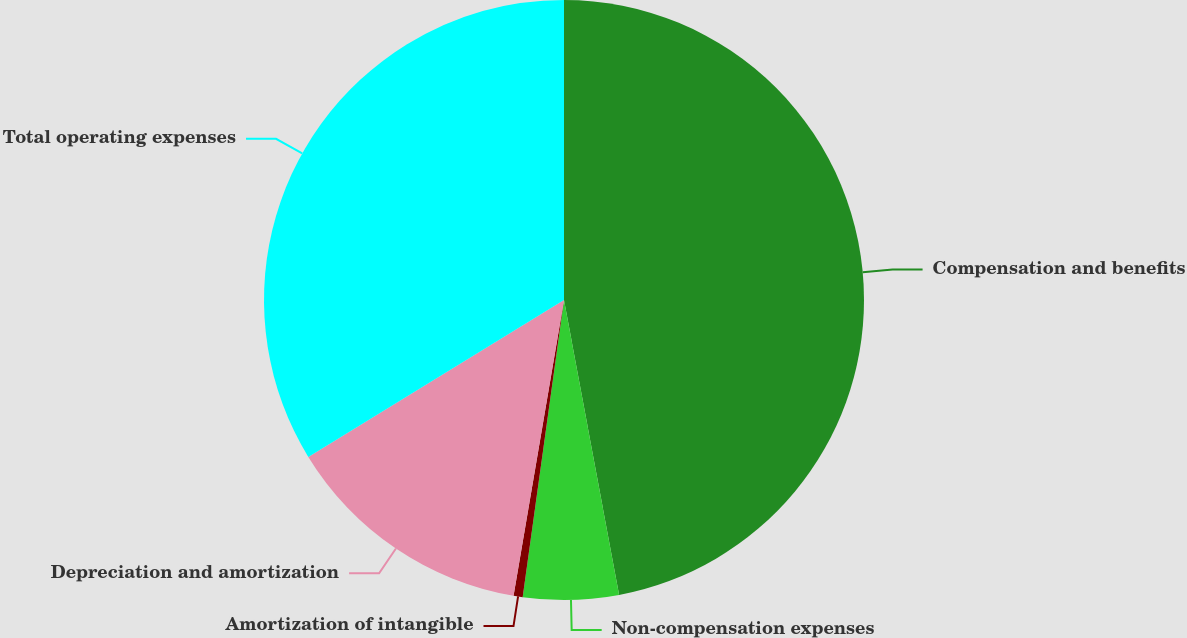Convert chart to OTSL. <chart><loc_0><loc_0><loc_500><loc_500><pie_chart><fcel>Compensation and benefits<fcel>Non-compensation expenses<fcel>Amortization of intangible<fcel>Depreciation and amortization<fcel>Total operating expenses<nl><fcel>47.06%<fcel>5.14%<fcel>0.49%<fcel>13.55%<fcel>33.76%<nl></chart> 